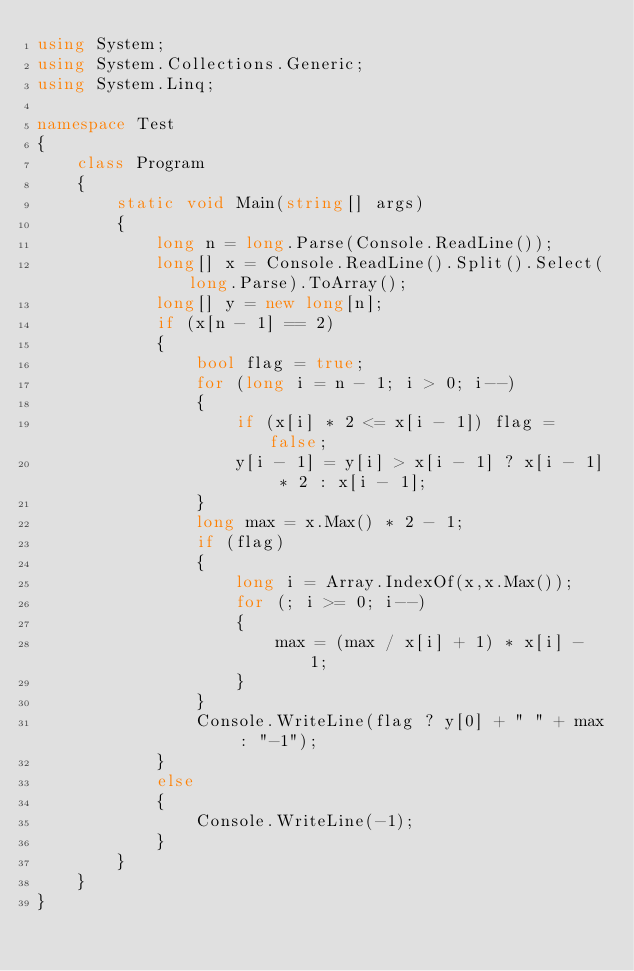Convert code to text. <code><loc_0><loc_0><loc_500><loc_500><_C#_>using System;
using System.Collections.Generic;
using System.Linq;

namespace Test
{
    class Program
    {
        static void Main(string[] args)
        {
            long n = long.Parse(Console.ReadLine());
            long[] x = Console.ReadLine().Split().Select(long.Parse).ToArray();
            long[] y = new long[n];
            if (x[n - 1] == 2)
            {
                bool flag = true;
                for (long i = n - 1; i > 0; i--)
                {
                    if (x[i] * 2 <= x[i - 1]) flag = false;
                    y[i - 1] = y[i] > x[i - 1] ? x[i - 1] * 2 : x[i - 1];
                }
                long max = x.Max() * 2 - 1;
                if (flag)
                {
                    long i = Array.IndexOf(x,x.Max());
                    for (; i >= 0; i--)
                    {
                        max = (max / x[i] + 1) * x[i] - 1;
                    }
                }
                Console.WriteLine(flag ? y[0] + " " + max : "-1");
            }
            else
            {
                Console.WriteLine(-1);
            }
        }
    }
}</code> 